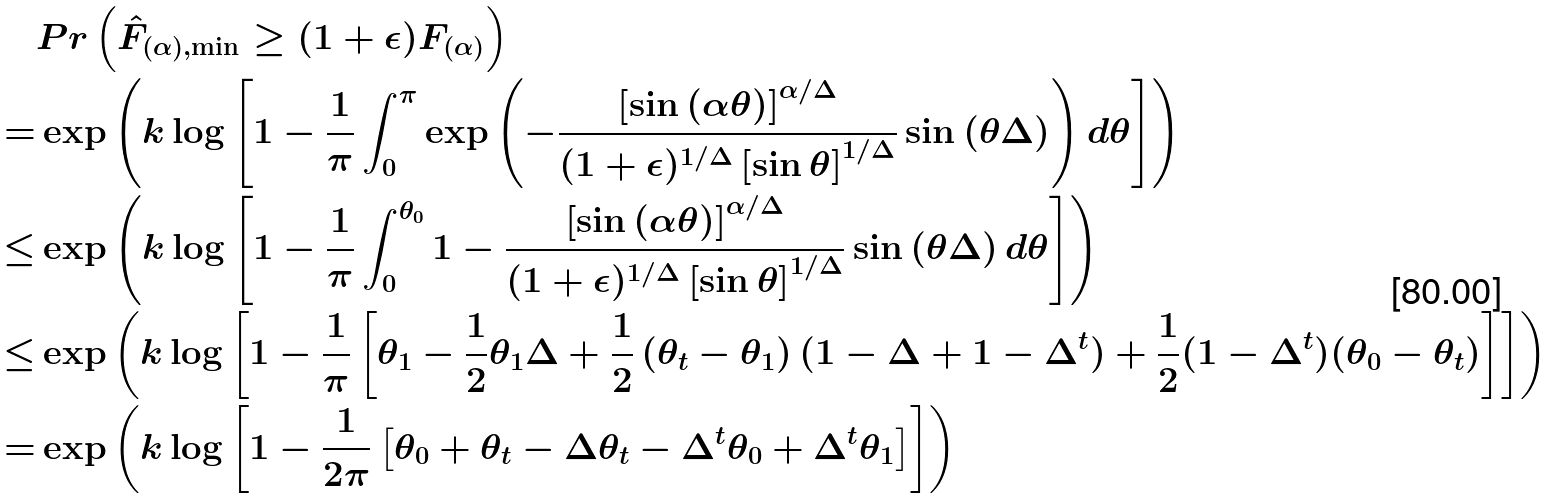<formula> <loc_0><loc_0><loc_500><loc_500>& P r \left ( \hat { F } _ { ( \alpha ) , \min } \geq ( 1 + \epsilon ) F _ { ( \alpha ) } \right ) \\ = & \exp \left ( k \log \left [ 1 - \frac { 1 } { \pi } \int _ { 0 } ^ { \pi } \exp \left ( - \frac { \left [ \sin \left ( \alpha \theta \right ) \right ] ^ { \alpha / \Delta } } { ( 1 + \epsilon ) ^ { 1 / \Delta } \left [ \sin \theta \right ] ^ { 1 / \Delta } } \sin \left ( \theta \Delta \right ) \right ) d \theta \right ] \right ) \\ \leq & \exp \left ( k \log \left [ 1 - \frac { 1 } { \pi } \int _ { 0 } ^ { \theta _ { 0 } } 1 - \frac { \left [ \sin \left ( \alpha \theta \right ) \right ] ^ { \alpha / \Delta } } { ( 1 + \epsilon ) ^ { 1 / \Delta } \left [ \sin \theta \right ] ^ { 1 / \Delta } } \sin \left ( \theta \Delta \right ) d \theta \right ] \right ) \\ \leq & \exp \left ( k \log \left [ 1 - \frac { 1 } { \pi } \left [ \theta _ { 1 } - \frac { 1 } { 2 } \theta _ { 1 } \Delta + \frac { 1 } { 2 } \left ( \theta _ { t } - \theta _ { 1 } \right ) ( 1 - \Delta + 1 - \Delta ^ { t } ) + \frac { 1 } { 2 } ( 1 - \Delta ^ { t } ) ( \theta _ { 0 } - \theta _ { t } ) \right ] \right ] \right ) \\ = & \exp \left ( k \log \left [ 1 - \frac { 1 } { 2 \pi } \left [ \theta _ { 0 } + \theta _ { t } - \Delta \theta _ { t } - \Delta ^ { t } \theta _ { 0 } + \Delta ^ { t } \theta _ { 1 } \right ] \right ] \right ) \\</formula> 